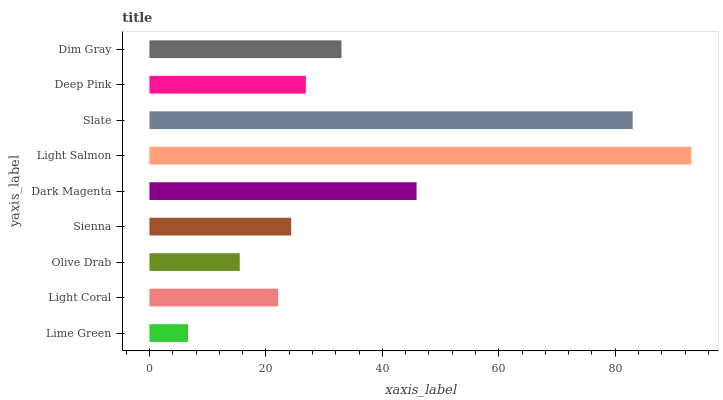Is Lime Green the minimum?
Answer yes or no. Yes. Is Light Salmon the maximum?
Answer yes or no. Yes. Is Light Coral the minimum?
Answer yes or no. No. Is Light Coral the maximum?
Answer yes or no. No. Is Light Coral greater than Lime Green?
Answer yes or no. Yes. Is Lime Green less than Light Coral?
Answer yes or no. Yes. Is Lime Green greater than Light Coral?
Answer yes or no. No. Is Light Coral less than Lime Green?
Answer yes or no. No. Is Deep Pink the high median?
Answer yes or no. Yes. Is Deep Pink the low median?
Answer yes or no. Yes. Is Light Salmon the high median?
Answer yes or no. No. Is Sienna the low median?
Answer yes or no. No. 